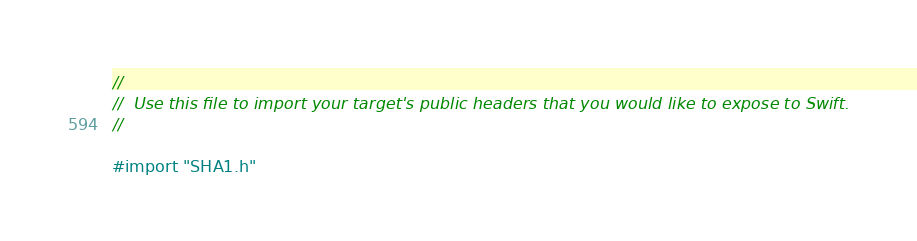<code> <loc_0><loc_0><loc_500><loc_500><_C_>//
//  Use this file to import your target's public headers that you would like to expose to Swift.
//

#import "SHA1.h"
</code> 